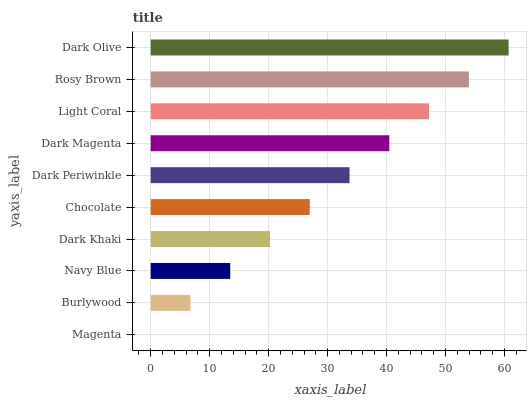Is Magenta the minimum?
Answer yes or no. Yes. Is Dark Olive the maximum?
Answer yes or no. Yes. Is Burlywood the minimum?
Answer yes or no. No. Is Burlywood the maximum?
Answer yes or no. No. Is Burlywood greater than Magenta?
Answer yes or no. Yes. Is Magenta less than Burlywood?
Answer yes or no. Yes. Is Magenta greater than Burlywood?
Answer yes or no. No. Is Burlywood less than Magenta?
Answer yes or no. No. Is Dark Periwinkle the high median?
Answer yes or no. Yes. Is Chocolate the low median?
Answer yes or no. Yes. Is Burlywood the high median?
Answer yes or no. No. Is Dark Periwinkle the low median?
Answer yes or no. No. 